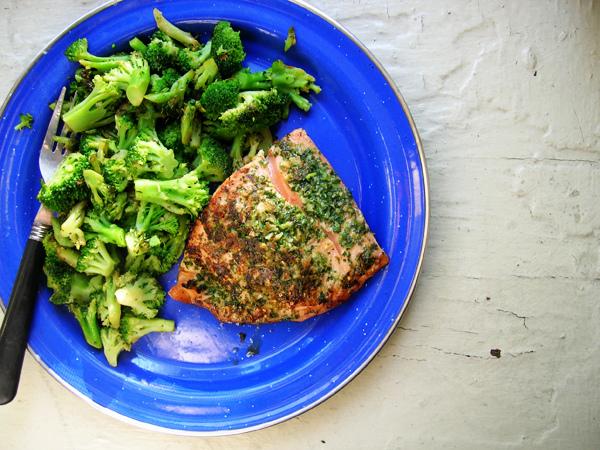What kind of utensil is being used?
Keep it brief. Fork. What color is the plate?
Give a very brief answer. Blue. What color is the vegetable?
Give a very brief answer. Green. 